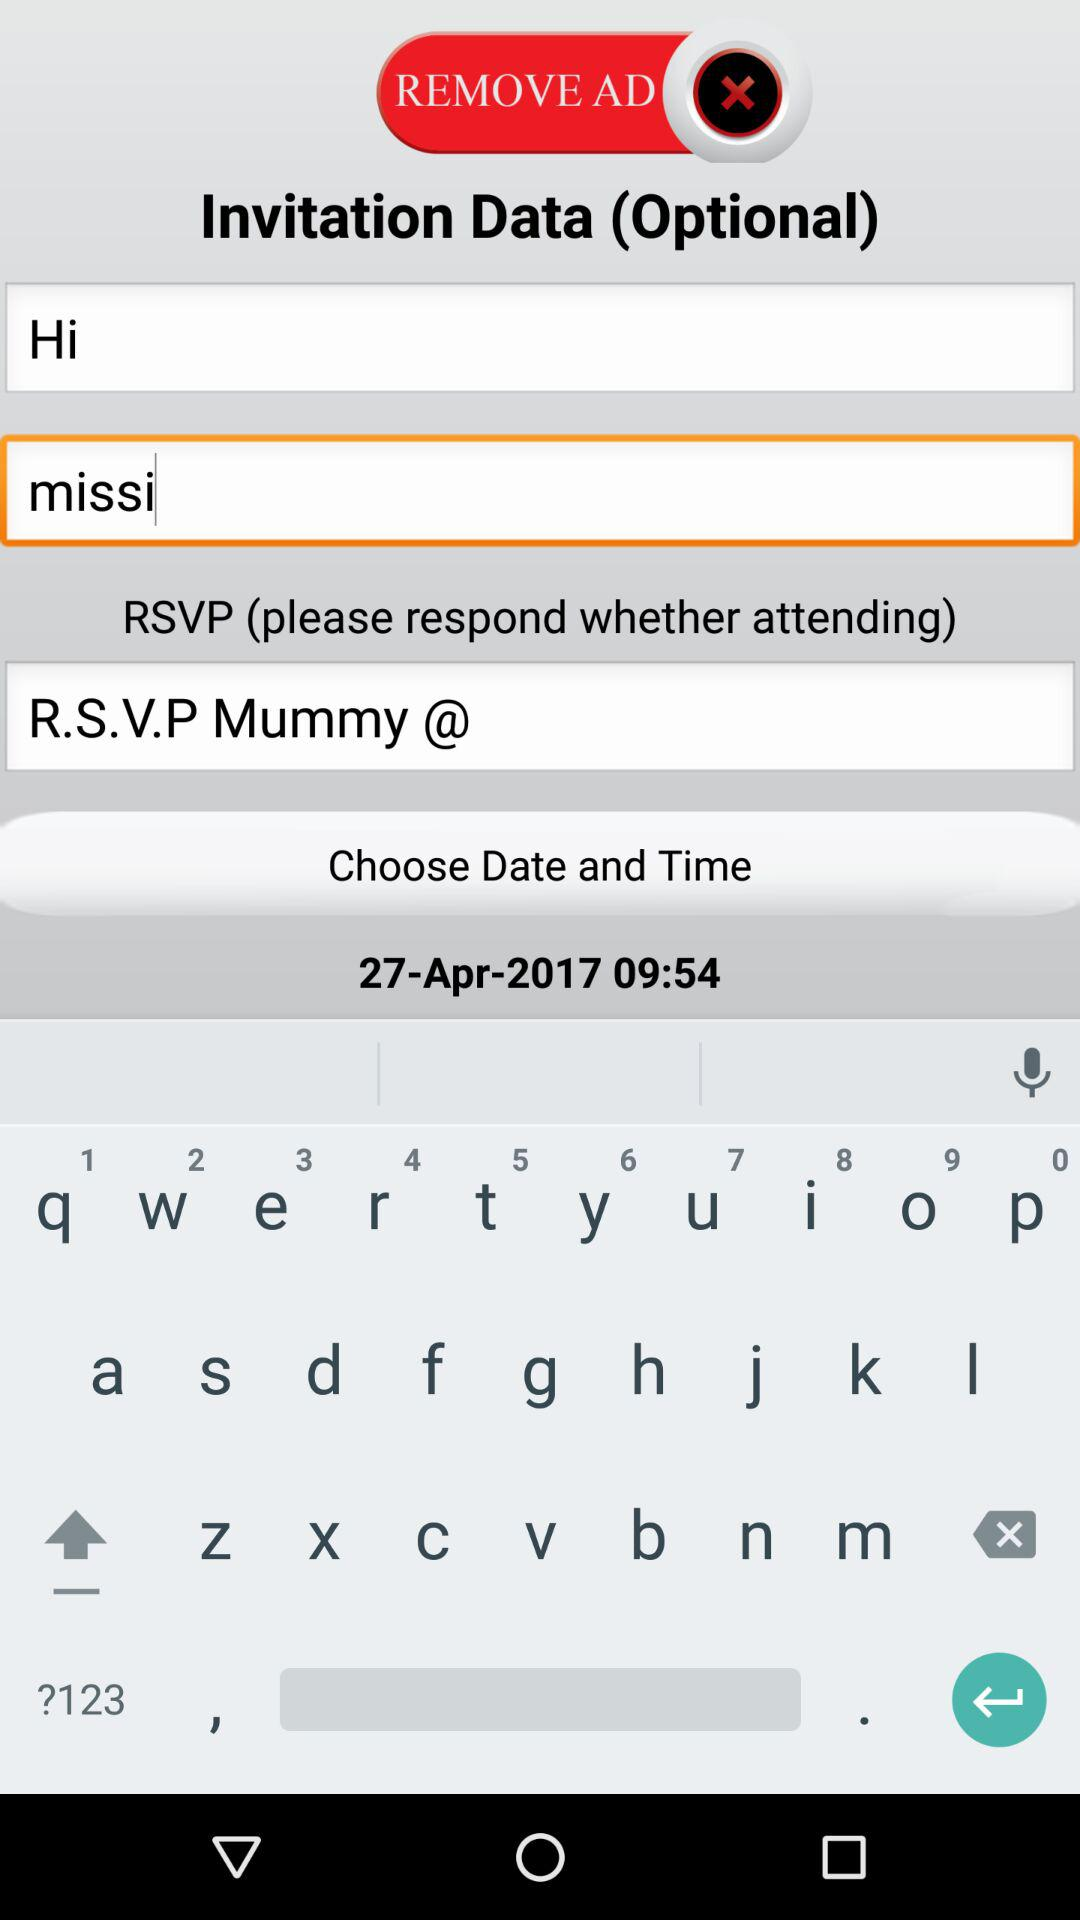What is the time? The time is 09:54. 